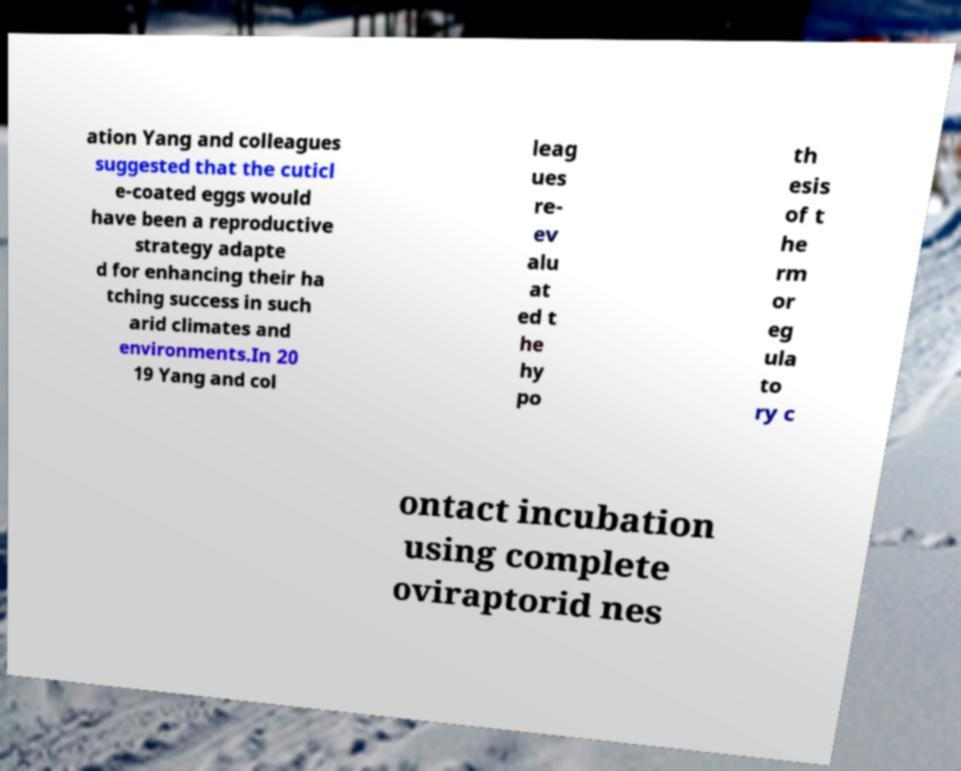Can you read and provide the text displayed in the image?This photo seems to have some interesting text. Can you extract and type it out for me? ation Yang and colleagues suggested that the cuticl e-coated eggs would have been a reproductive strategy adapte d for enhancing their ha tching success in such arid climates and environments.In 20 19 Yang and col leag ues re- ev alu at ed t he hy po th esis of t he rm or eg ula to ry c ontact incubation using complete oviraptorid nes 